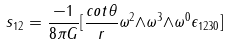<formula> <loc_0><loc_0><loc_500><loc_500>s _ { 1 2 } = \frac { - 1 } { 8 { \pi } G } [ \frac { c o t { \theta } } { r } { \omega } ^ { 2 } { \wedge } { \omega } ^ { 3 } { \wedge } { \omega } ^ { 0 } { \epsilon } _ { 1 2 3 0 } ]</formula> 